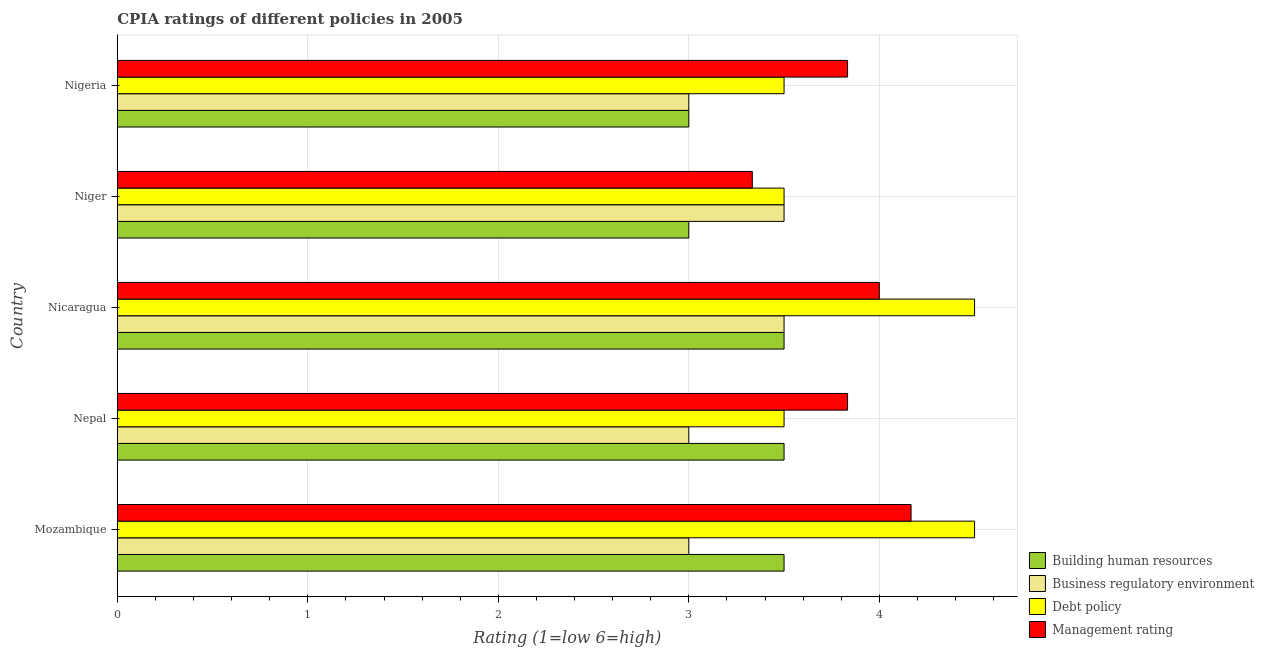How many different coloured bars are there?
Give a very brief answer. 4. How many groups of bars are there?
Give a very brief answer. 5. How many bars are there on the 3rd tick from the top?
Offer a terse response. 4. What is the label of the 2nd group of bars from the top?
Keep it short and to the point. Niger. What is the cpia rating of management in Nepal?
Offer a terse response. 3.83. In which country was the cpia rating of debt policy maximum?
Your response must be concise. Mozambique. In which country was the cpia rating of management minimum?
Provide a succinct answer. Niger. What is the total cpia rating of management in the graph?
Offer a very short reply. 19.17. What is the difference between the cpia rating of management in Mozambique and that in Nicaragua?
Offer a terse response. 0.17. What is the difference between the cpia rating of debt policy in Mozambique and the cpia rating of building human resources in Niger?
Give a very brief answer. 1.5. What is the average cpia rating of management per country?
Provide a short and direct response. 3.83. In how many countries, is the cpia rating of management greater than 3.4 ?
Make the answer very short. 4. What is the ratio of the cpia rating of building human resources in Mozambique to that in Nigeria?
Provide a short and direct response. 1.17. Is the cpia rating of debt policy in Nepal less than that in Nicaragua?
Provide a short and direct response. Yes. What is the difference between the highest and the second highest cpia rating of business regulatory environment?
Offer a very short reply. 0. Is the sum of the cpia rating of building human resources in Mozambique and Nicaragua greater than the maximum cpia rating of business regulatory environment across all countries?
Provide a succinct answer. Yes. Is it the case that in every country, the sum of the cpia rating of building human resources and cpia rating of debt policy is greater than the sum of cpia rating of management and cpia rating of business regulatory environment?
Offer a very short reply. No. What does the 2nd bar from the top in Niger represents?
Keep it short and to the point. Debt policy. What does the 3rd bar from the bottom in Mozambique represents?
Keep it short and to the point. Debt policy. What is the difference between two consecutive major ticks on the X-axis?
Ensure brevity in your answer.  1. Does the graph contain grids?
Offer a very short reply. Yes. How many legend labels are there?
Your answer should be compact. 4. How are the legend labels stacked?
Your answer should be compact. Vertical. What is the title of the graph?
Your answer should be very brief. CPIA ratings of different policies in 2005. Does "Social Assistance" appear as one of the legend labels in the graph?
Provide a succinct answer. No. What is the Rating (1=low 6=high) of Business regulatory environment in Mozambique?
Provide a succinct answer. 3. What is the Rating (1=low 6=high) in Debt policy in Mozambique?
Ensure brevity in your answer.  4.5. What is the Rating (1=low 6=high) in Management rating in Mozambique?
Your response must be concise. 4.17. What is the Rating (1=low 6=high) of Business regulatory environment in Nepal?
Give a very brief answer. 3. What is the Rating (1=low 6=high) in Debt policy in Nepal?
Give a very brief answer. 3.5. What is the Rating (1=low 6=high) in Management rating in Nepal?
Provide a succinct answer. 3.83. What is the Rating (1=low 6=high) in Building human resources in Nicaragua?
Your answer should be compact. 3.5. What is the Rating (1=low 6=high) of Management rating in Nicaragua?
Make the answer very short. 4. What is the Rating (1=low 6=high) in Business regulatory environment in Niger?
Offer a very short reply. 3.5. What is the Rating (1=low 6=high) of Debt policy in Niger?
Give a very brief answer. 3.5. What is the Rating (1=low 6=high) of Management rating in Niger?
Offer a terse response. 3.33. What is the Rating (1=low 6=high) in Debt policy in Nigeria?
Offer a very short reply. 3.5. What is the Rating (1=low 6=high) of Management rating in Nigeria?
Give a very brief answer. 3.83. Across all countries, what is the maximum Rating (1=low 6=high) of Building human resources?
Offer a terse response. 3.5. Across all countries, what is the maximum Rating (1=low 6=high) of Business regulatory environment?
Give a very brief answer. 3.5. Across all countries, what is the maximum Rating (1=low 6=high) in Management rating?
Keep it short and to the point. 4.17. Across all countries, what is the minimum Rating (1=low 6=high) of Business regulatory environment?
Your answer should be very brief. 3. Across all countries, what is the minimum Rating (1=low 6=high) in Management rating?
Your response must be concise. 3.33. What is the total Rating (1=low 6=high) in Debt policy in the graph?
Provide a short and direct response. 19.5. What is the total Rating (1=low 6=high) of Management rating in the graph?
Ensure brevity in your answer.  19.17. What is the difference between the Rating (1=low 6=high) of Management rating in Mozambique and that in Nepal?
Offer a very short reply. 0.33. What is the difference between the Rating (1=low 6=high) in Debt policy in Mozambique and that in Nicaragua?
Your response must be concise. 0. What is the difference between the Rating (1=low 6=high) of Building human resources in Mozambique and that in Niger?
Provide a short and direct response. 0.5. What is the difference between the Rating (1=low 6=high) of Debt policy in Mozambique and that in Niger?
Ensure brevity in your answer.  1. What is the difference between the Rating (1=low 6=high) in Management rating in Mozambique and that in Niger?
Your response must be concise. 0.83. What is the difference between the Rating (1=low 6=high) in Business regulatory environment in Mozambique and that in Nigeria?
Give a very brief answer. 0. What is the difference between the Rating (1=low 6=high) in Building human resources in Nepal and that in Nicaragua?
Your answer should be compact. 0. What is the difference between the Rating (1=low 6=high) of Management rating in Nepal and that in Nicaragua?
Ensure brevity in your answer.  -0.17. What is the difference between the Rating (1=low 6=high) of Business regulatory environment in Nepal and that in Niger?
Provide a short and direct response. -0.5. What is the difference between the Rating (1=low 6=high) of Debt policy in Nepal and that in Niger?
Provide a short and direct response. 0. What is the difference between the Rating (1=low 6=high) in Building human resources in Nepal and that in Nigeria?
Offer a terse response. 0.5. What is the difference between the Rating (1=low 6=high) of Business regulatory environment in Nepal and that in Nigeria?
Keep it short and to the point. 0. What is the difference between the Rating (1=low 6=high) in Debt policy in Nepal and that in Nigeria?
Provide a short and direct response. 0. What is the difference between the Rating (1=low 6=high) in Business regulatory environment in Nicaragua and that in Niger?
Your answer should be compact. 0. What is the difference between the Rating (1=low 6=high) of Debt policy in Nicaragua and that in Niger?
Offer a very short reply. 1. What is the difference between the Rating (1=low 6=high) in Management rating in Nicaragua and that in Niger?
Give a very brief answer. 0.67. What is the difference between the Rating (1=low 6=high) of Building human resources in Nicaragua and that in Nigeria?
Your answer should be very brief. 0.5. What is the difference between the Rating (1=low 6=high) in Business regulatory environment in Nicaragua and that in Nigeria?
Your answer should be compact. 0.5. What is the difference between the Rating (1=low 6=high) of Debt policy in Nicaragua and that in Nigeria?
Offer a very short reply. 1. What is the difference between the Rating (1=low 6=high) of Management rating in Nicaragua and that in Nigeria?
Keep it short and to the point. 0.17. What is the difference between the Rating (1=low 6=high) of Management rating in Niger and that in Nigeria?
Provide a short and direct response. -0.5. What is the difference between the Rating (1=low 6=high) of Building human resources in Mozambique and the Rating (1=low 6=high) of Management rating in Nepal?
Your response must be concise. -0.33. What is the difference between the Rating (1=low 6=high) of Business regulatory environment in Mozambique and the Rating (1=low 6=high) of Debt policy in Nepal?
Provide a succinct answer. -0.5. What is the difference between the Rating (1=low 6=high) in Building human resources in Mozambique and the Rating (1=low 6=high) in Business regulatory environment in Nicaragua?
Make the answer very short. 0. What is the difference between the Rating (1=low 6=high) in Building human resources in Mozambique and the Rating (1=low 6=high) in Debt policy in Nicaragua?
Ensure brevity in your answer.  -1. What is the difference between the Rating (1=low 6=high) in Building human resources in Mozambique and the Rating (1=low 6=high) in Management rating in Nicaragua?
Ensure brevity in your answer.  -0.5. What is the difference between the Rating (1=low 6=high) in Business regulatory environment in Mozambique and the Rating (1=low 6=high) in Debt policy in Nicaragua?
Offer a terse response. -1.5. What is the difference between the Rating (1=low 6=high) in Debt policy in Mozambique and the Rating (1=low 6=high) in Management rating in Niger?
Keep it short and to the point. 1.17. What is the difference between the Rating (1=low 6=high) of Building human resources in Mozambique and the Rating (1=low 6=high) of Management rating in Nigeria?
Ensure brevity in your answer.  -0.33. What is the difference between the Rating (1=low 6=high) of Business regulatory environment in Mozambique and the Rating (1=low 6=high) of Debt policy in Nigeria?
Make the answer very short. -0.5. What is the difference between the Rating (1=low 6=high) in Business regulatory environment in Mozambique and the Rating (1=low 6=high) in Management rating in Nigeria?
Keep it short and to the point. -0.83. What is the difference between the Rating (1=low 6=high) of Debt policy in Mozambique and the Rating (1=low 6=high) of Management rating in Nigeria?
Make the answer very short. 0.67. What is the difference between the Rating (1=low 6=high) of Building human resources in Nepal and the Rating (1=low 6=high) of Debt policy in Nicaragua?
Offer a terse response. -1. What is the difference between the Rating (1=low 6=high) in Business regulatory environment in Nepal and the Rating (1=low 6=high) in Debt policy in Nicaragua?
Your response must be concise. -1.5. What is the difference between the Rating (1=low 6=high) of Business regulatory environment in Nepal and the Rating (1=low 6=high) of Management rating in Nicaragua?
Provide a short and direct response. -1. What is the difference between the Rating (1=low 6=high) in Building human resources in Nepal and the Rating (1=low 6=high) in Business regulatory environment in Niger?
Provide a short and direct response. 0. What is the difference between the Rating (1=low 6=high) in Building human resources in Nepal and the Rating (1=low 6=high) in Management rating in Niger?
Make the answer very short. 0.17. What is the difference between the Rating (1=low 6=high) of Building human resources in Nepal and the Rating (1=low 6=high) of Business regulatory environment in Nigeria?
Provide a short and direct response. 0.5. What is the difference between the Rating (1=low 6=high) of Building human resources in Nepal and the Rating (1=low 6=high) of Management rating in Nigeria?
Give a very brief answer. -0.33. What is the difference between the Rating (1=low 6=high) of Business regulatory environment in Nepal and the Rating (1=low 6=high) of Debt policy in Nigeria?
Provide a succinct answer. -0.5. What is the difference between the Rating (1=low 6=high) of Business regulatory environment in Nicaragua and the Rating (1=low 6=high) of Debt policy in Niger?
Your answer should be compact. 0. What is the difference between the Rating (1=low 6=high) of Debt policy in Nicaragua and the Rating (1=low 6=high) of Management rating in Niger?
Provide a succinct answer. 1.17. What is the difference between the Rating (1=low 6=high) in Building human resources in Nicaragua and the Rating (1=low 6=high) in Business regulatory environment in Nigeria?
Offer a terse response. 0.5. What is the difference between the Rating (1=low 6=high) in Building human resources in Nicaragua and the Rating (1=low 6=high) in Management rating in Nigeria?
Offer a terse response. -0.33. What is the difference between the Rating (1=low 6=high) of Business regulatory environment in Nicaragua and the Rating (1=low 6=high) of Debt policy in Nigeria?
Provide a short and direct response. 0. What is the difference between the Rating (1=low 6=high) of Business regulatory environment in Nicaragua and the Rating (1=low 6=high) of Management rating in Nigeria?
Your answer should be very brief. -0.33. What is the difference between the Rating (1=low 6=high) in Building human resources in Niger and the Rating (1=low 6=high) in Debt policy in Nigeria?
Make the answer very short. -0.5. What is the difference between the Rating (1=low 6=high) in Building human resources in Niger and the Rating (1=low 6=high) in Management rating in Nigeria?
Ensure brevity in your answer.  -0.83. What is the difference between the Rating (1=low 6=high) of Debt policy in Niger and the Rating (1=low 6=high) of Management rating in Nigeria?
Your response must be concise. -0.33. What is the average Rating (1=low 6=high) in Business regulatory environment per country?
Your answer should be compact. 3.2. What is the average Rating (1=low 6=high) in Management rating per country?
Make the answer very short. 3.83. What is the difference between the Rating (1=low 6=high) of Business regulatory environment and Rating (1=low 6=high) of Management rating in Mozambique?
Your answer should be very brief. -1.17. What is the difference between the Rating (1=low 6=high) in Building human resources and Rating (1=low 6=high) in Business regulatory environment in Nepal?
Provide a succinct answer. 0.5. What is the difference between the Rating (1=low 6=high) in Building human resources and Rating (1=low 6=high) in Management rating in Nepal?
Give a very brief answer. -0.33. What is the difference between the Rating (1=low 6=high) of Business regulatory environment and Rating (1=low 6=high) of Debt policy in Nepal?
Ensure brevity in your answer.  -0.5. What is the difference between the Rating (1=low 6=high) of Debt policy and Rating (1=low 6=high) of Management rating in Nepal?
Offer a terse response. -0.33. What is the difference between the Rating (1=low 6=high) of Debt policy and Rating (1=low 6=high) of Management rating in Nicaragua?
Your answer should be very brief. 0.5. What is the difference between the Rating (1=low 6=high) of Building human resources and Rating (1=low 6=high) of Business regulatory environment in Niger?
Provide a short and direct response. -0.5. What is the difference between the Rating (1=low 6=high) in Building human resources and Rating (1=low 6=high) in Debt policy in Niger?
Ensure brevity in your answer.  -0.5. What is the difference between the Rating (1=low 6=high) in Building human resources and Rating (1=low 6=high) in Management rating in Niger?
Give a very brief answer. -0.33. What is the difference between the Rating (1=low 6=high) in Business regulatory environment and Rating (1=low 6=high) in Debt policy in Niger?
Give a very brief answer. 0. What is the difference between the Rating (1=low 6=high) in Business regulatory environment and Rating (1=low 6=high) in Management rating in Niger?
Provide a short and direct response. 0.17. What is the difference between the Rating (1=low 6=high) in Building human resources and Rating (1=low 6=high) in Management rating in Nigeria?
Give a very brief answer. -0.83. What is the ratio of the Rating (1=low 6=high) in Building human resources in Mozambique to that in Nepal?
Keep it short and to the point. 1. What is the ratio of the Rating (1=low 6=high) of Business regulatory environment in Mozambique to that in Nepal?
Provide a short and direct response. 1. What is the ratio of the Rating (1=low 6=high) of Debt policy in Mozambique to that in Nepal?
Make the answer very short. 1.29. What is the ratio of the Rating (1=low 6=high) of Management rating in Mozambique to that in Nepal?
Your answer should be compact. 1.09. What is the ratio of the Rating (1=low 6=high) of Building human resources in Mozambique to that in Nicaragua?
Keep it short and to the point. 1. What is the ratio of the Rating (1=low 6=high) in Management rating in Mozambique to that in Nicaragua?
Provide a short and direct response. 1.04. What is the ratio of the Rating (1=low 6=high) of Business regulatory environment in Mozambique to that in Niger?
Your answer should be compact. 0.86. What is the ratio of the Rating (1=low 6=high) of Management rating in Mozambique to that in Niger?
Give a very brief answer. 1.25. What is the ratio of the Rating (1=low 6=high) in Debt policy in Mozambique to that in Nigeria?
Provide a short and direct response. 1.29. What is the ratio of the Rating (1=low 6=high) of Management rating in Mozambique to that in Nigeria?
Provide a succinct answer. 1.09. What is the ratio of the Rating (1=low 6=high) in Business regulatory environment in Nepal to that in Nicaragua?
Provide a succinct answer. 0.86. What is the ratio of the Rating (1=low 6=high) of Management rating in Nepal to that in Nicaragua?
Provide a short and direct response. 0.96. What is the ratio of the Rating (1=low 6=high) in Building human resources in Nepal to that in Niger?
Your answer should be very brief. 1.17. What is the ratio of the Rating (1=low 6=high) of Business regulatory environment in Nepal to that in Niger?
Provide a short and direct response. 0.86. What is the ratio of the Rating (1=low 6=high) in Management rating in Nepal to that in Niger?
Provide a succinct answer. 1.15. What is the ratio of the Rating (1=low 6=high) in Building human resources in Nepal to that in Nigeria?
Give a very brief answer. 1.17. What is the ratio of the Rating (1=low 6=high) in Business regulatory environment in Nepal to that in Nigeria?
Offer a very short reply. 1. What is the ratio of the Rating (1=low 6=high) of Management rating in Nepal to that in Nigeria?
Provide a short and direct response. 1. What is the ratio of the Rating (1=low 6=high) of Building human resources in Nicaragua to that in Niger?
Give a very brief answer. 1.17. What is the ratio of the Rating (1=low 6=high) of Debt policy in Nicaragua to that in Niger?
Make the answer very short. 1.29. What is the ratio of the Rating (1=low 6=high) of Building human resources in Nicaragua to that in Nigeria?
Provide a succinct answer. 1.17. What is the ratio of the Rating (1=low 6=high) of Debt policy in Nicaragua to that in Nigeria?
Give a very brief answer. 1.29. What is the ratio of the Rating (1=low 6=high) of Management rating in Nicaragua to that in Nigeria?
Keep it short and to the point. 1.04. What is the ratio of the Rating (1=low 6=high) of Building human resources in Niger to that in Nigeria?
Your answer should be very brief. 1. What is the ratio of the Rating (1=low 6=high) in Business regulatory environment in Niger to that in Nigeria?
Offer a terse response. 1.17. What is the ratio of the Rating (1=low 6=high) in Debt policy in Niger to that in Nigeria?
Your answer should be compact. 1. What is the ratio of the Rating (1=low 6=high) of Management rating in Niger to that in Nigeria?
Offer a terse response. 0.87. What is the difference between the highest and the second highest Rating (1=low 6=high) of Building human resources?
Your answer should be compact. 0. What is the difference between the highest and the second highest Rating (1=low 6=high) in Debt policy?
Provide a succinct answer. 0. What is the difference between the highest and the second highest Rating (1=low 6=high) in Management rating?
Give a very brief answer. 0.17. What is the difference between the highest and the lowest Rating (1=low 6=high) in Business regulatory environment?
Offer a terse response. 0.5. What is the difference between the highest and the lowest Rating (1=low 6=high) of Debt policy?
Ensure brevity in your answer.  1. 